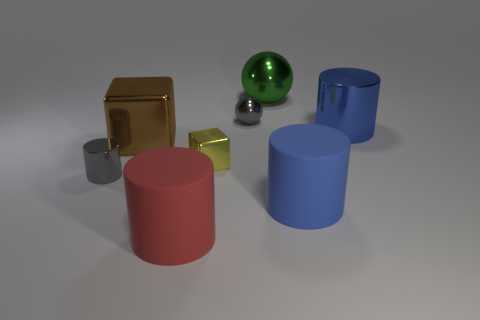Subtract 1 cylinders. How many cylinders are left? 3 Subtract all red cylinders. How many cylinders are left? 3 Subtract all brown cylinders. Subtract all yellow cubes. How many cylinders are left? 4 Add 1 big red cylinders. How many objects exist? 9 Subtract all spheres. How many objects are left? 6 Add 1 green balls. How many green balls are left? 2 Add 7 blue matte objects. How many blue matte objects exist? 8 Subtract 1 brown blocks. How many objects are left? 7 Subtract all gray metal things. Subtract all brown spheres. How many objects are left? 6 